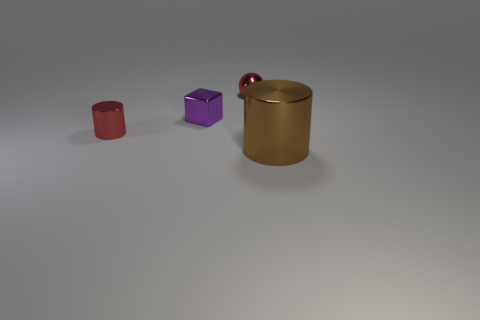Is the number of red shiny objects to the right of the small red cylinder greater than the number of red metallic balls?
Your answer should be very brief. No. How many big brown shiny cylinders are left of the tiny red shiny cylinder that is in front of the red object that is behind the red metallic cylinder?
Keep it short and to the point. 0. Do the red metal thing that is to the left of the ball and the thing that is behind the purple cube have the same size?
Provide a succinct answer. Yes. What material is the cylinder on the right side of the metallic cylinder that is behind the big cylinder made of?
Make the answer very short. Metal. What number of things are objects left of the big brown thing or small things?
Your answer should be compact. 3. Is the number of brown cylinders that are on the right side of the brown cylinder the same as the number of tiny purple cubes right of the cube?
Your answer should be compact. Yes. There is a object that is on the right side of the red metallic thing right of the tiny red thing that is on the left side of the sphere; what is its material?
Offer a very short reply. Metal. There is a metallic thing that is left of the tiny metallic ball and on the right side of the tiny cylinder; how big is it?
Give a very brief answer. Small. What shape is the purple thing that is made of the same material as the brown cylinder?
Provide a succinct answer. Cube. How many big things are red metal balls or gray cylinders?
Offer a very short reply. 0. 